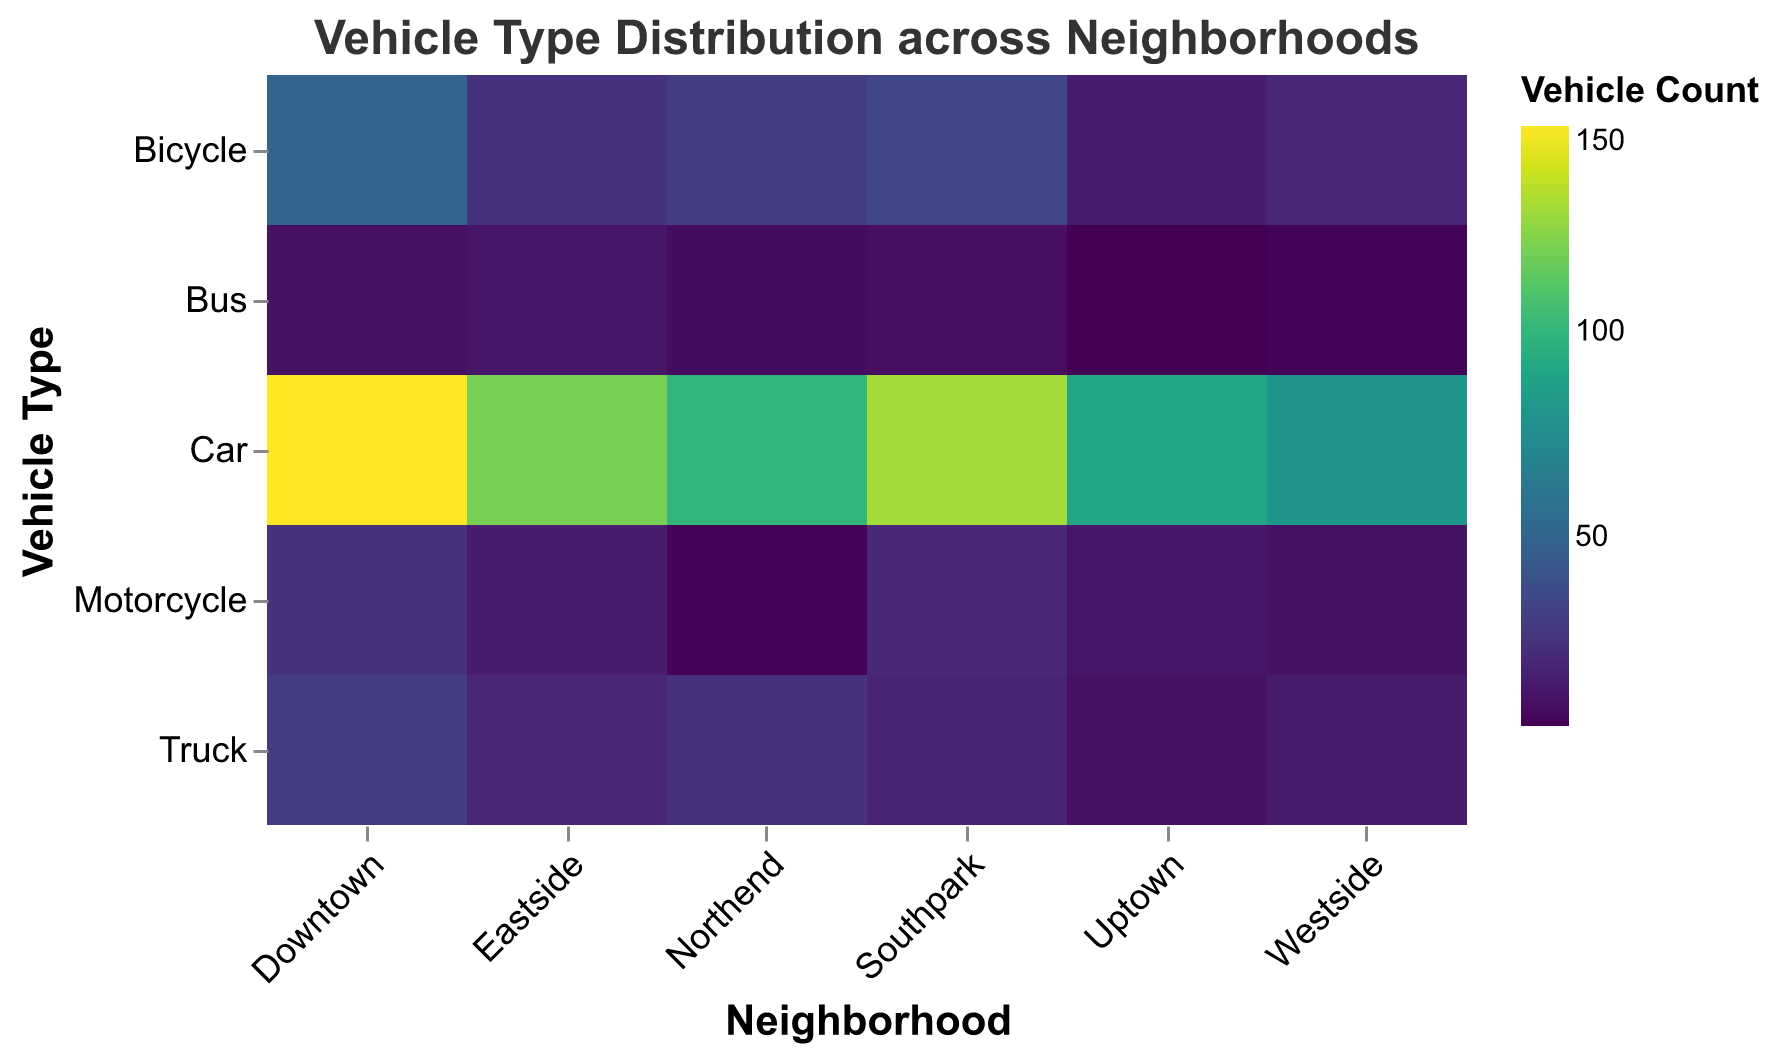What is the title of the heatmap? The title is located at the top of the heatmap and it reads "Vehicle Type Distribution across Neighborhoods" in Arial font.
Answer: Vehicle Type Distribution across Neighborhoods Which neighborhood has the highest count of cars? To find the neighborhood with the highest count of cars, look at the row for "Car" and identify the cell with the darkest color or the highest numerical value. Downtown has the highest count of 150 cars.
Answer: Downtown What is the total count of buses across all neighborhoods? Add up the bus counts from each neighborhood (10 + 5 + 12 + 8 + 9 + 4). This gives us a total of 48 buses.
Answer: 48 How many motorcycles are there in Eastside? Locate the intersection of Eastside and Motorcycle. The count is 15.
Answer: 15 Which neighborhood has the lowest count of trucks? Look at the row for "Truck" and compare the counts for each neighborhood. Uptown has the lowest count of 10 trucks.
Answer: Uptown What is the difference in the count of bicycles between Northend and Westside? Subtract the count of bicycles in Westside (20) from the count in Northend (30). This gives 30 - 20 = 10.
Answer: 10 Which vehicle type has the highest count in Southpark? Look at all the counts for Southpark, the highest value is 130 for Car.
Answer: Car Compare the count of buses between Downtown and Uptown. Which has more? Look at the bus counts for Downtown (10) and Uptown (4). Downtown has more buses.
Answer: Downtown What is the average count of cars across all neighborhoods? Add up the car counts (150 + 80 + 120 + 100 + 130 + 90) and divide by the number of neighborhoods (6). The total is 670, so the average is 670/6 = 111.67.
Answer: 111.67 In which neighborhoods are bicycles more common than motorcycles? Compare the counts of bicycles and motorcycles for each neighborhood: Downtown (50 vs 25), Westside (20 vs 10), Eastside (25 vs 15), Northend (30 vs 5), Southpark (35 vs 20), Uptown (15 vs 12). Bicycles are more common in all neighborhoods.
Answer: All Neighborhoods 